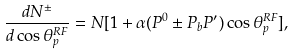Convert formula to latex. <formula><loc_0><loc_0><loc_500><loc_500>\frac { d N ^ { \pm } } { d \cos \theta _ { p } ^ { R F } } = N [ 1 + { \alpha } ( P ^ { 0 } \pm P _ { b } P ^ { \prime } ) \cos \theta _ { p } ^ { R F } ] ,</formula> 